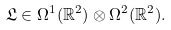<formula> <loc_0><loc_0><loc_500><loc_500>\mathfrak { L } \in \Omega ^ { 1 } ( \mathbb { R } ^ { 2 } ) \otimes \Omega ^ { 2 } ( \mathbb { R } ^ { 2 } ) .</formula> 